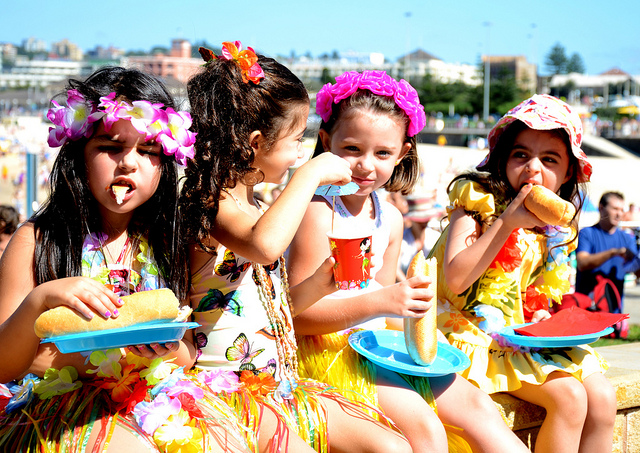<image>What snake are the children eating? The children are not eating a snake. It could be hot dogs. What snake are the children eating? It is unanswerable what snake the children are eating. 